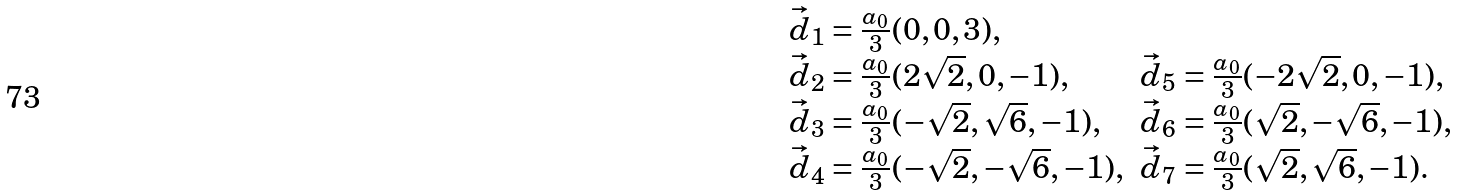<formula> <loc_0><loc_0><loc_500><loc_500>\begin{array} { l l } \vec { d } _ { 1 } = \frac { a _ { 0 } } { 3 } ( 0 , 0 , 3 ) , & \\ \vec { d } _ { 2 } = \frac { a _ { 0 } } { 3 } ( 2 \sqrt { 2 } , 0 , - 1 ) , & \vec { d } _ { 5 } = \frac { a _ { 0 } } { 3 } ( - 2 \sqrt { 2 } , 0 , - 1 ) , \\ \vec { d } _ { 3 } = \frac { a _ { 0 } } { 3 } ( - \sqrt { 2 } , \sqrt { 6 } , - 1 ) , & \vec { d } _ { 6 } = \frac { a _ { 0 } } { 3 } ( \sqrt { 2 } , - \sqrt { 6 } , - 1 ) , \\ \vec { d } _ { 4 } = \frac { a _ { 0 } } { 3 } ( - \sqrt { 2 } , - \sqrt { 6 } , - 1 ) , & \vec { d } _ { 7 } = \frac { a _ { 0 } } { 3 } ( \sqrt { 2 } , \sqrt { 6 } , - 1 ) . \end{array}</formula> 